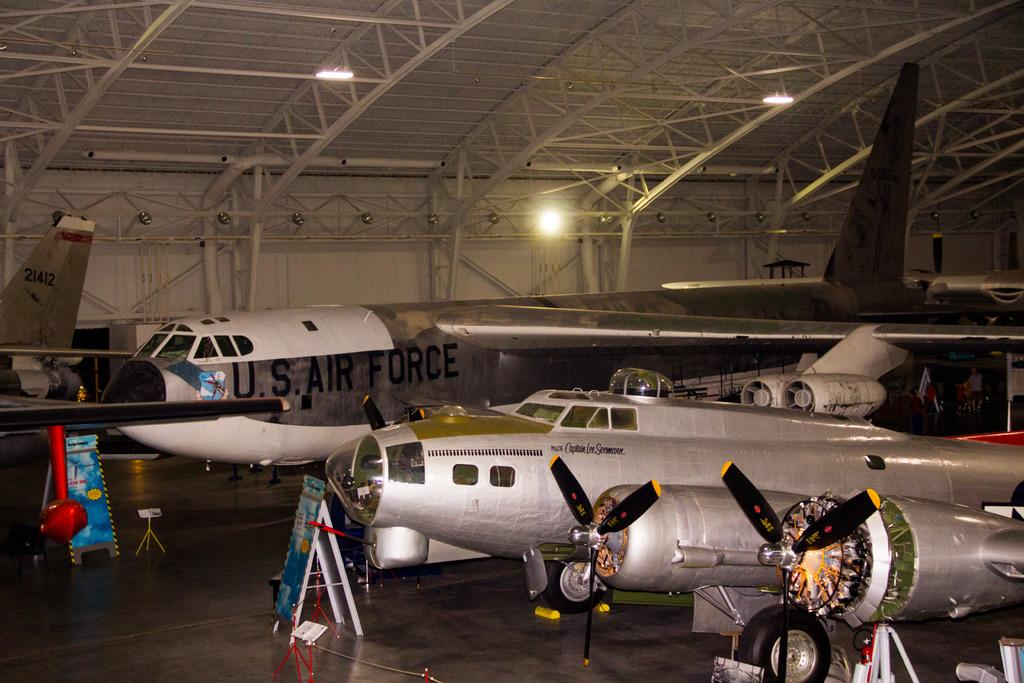<image>
Write a terse but informative summary of the picture. An airplane hangar with a collection of US Airforce planes in it. 